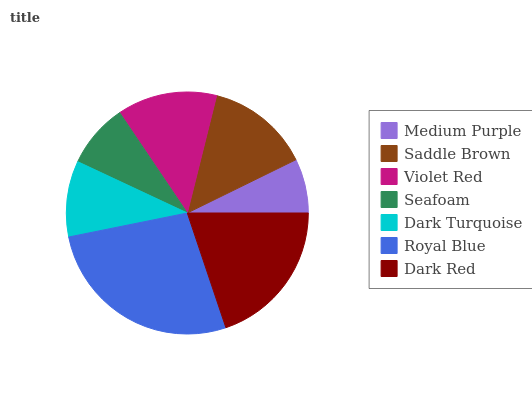Is Medium Purple the minimum?
Answer yes or no. Yes. Is Royal Blue the maximum?
Answer yes or no. Yes. Is Saddle Brown the minimum?
Answer yes or no. No. Is Saddle Brown the maximum?
Answer yes or no. No. Is Saddle Brown greater than Medium Purple?
Answer yes or no. Yes. Is Medium Purple less than Saddle Brown?
Answer yes or no. Yes. Is Medium Purple greater than Saddle Brown?
Answer yes or no. No. Is Saddle Brown less than Medium Purple?
Answer yes or no. No. Is Violet Red the high median?
Answer yes or no. Yes. Is Violet Red the low median?
Answer yes or no. Yes. Is Seafoam the high median?
Answer yes or no. No. Is Dark Turquoise the low median?
Answer yes or no. No. 